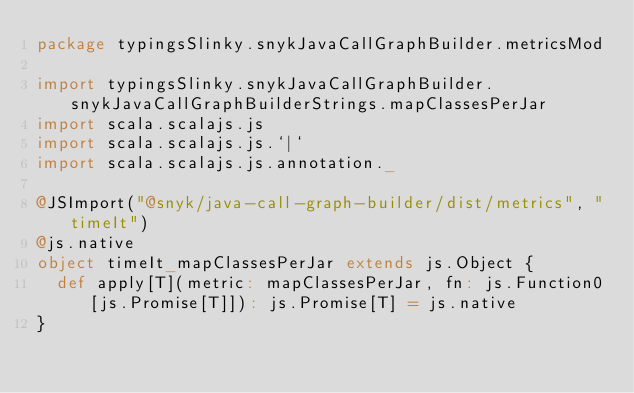Convert code to text. <code><loc_0><loc_0><loc_500><loc_500><_Scala_>package typingsSlinky.snykJavaCallGraphBuilder.metricsMod

import typingsSlinky.snykJavaCallGraphBuilder.snykJavaCallGraphBuilderStrings.mapClassesPerJar
import scala.scalajs.js
import scala.scalajs.js.`|`
import scala.scalajs.js.annotation._

@JSImport("@snyk/java-call-graph-builder/dist/metrics", "timeIt")
@js.native
object timeIt_mapClassesPerJar extends js.Object {
  def apply[T](metric: mapClassesPerJar, fn: js.Function0[js.Promise[T]]): js.Promise[T] = js.native
}

</code> 